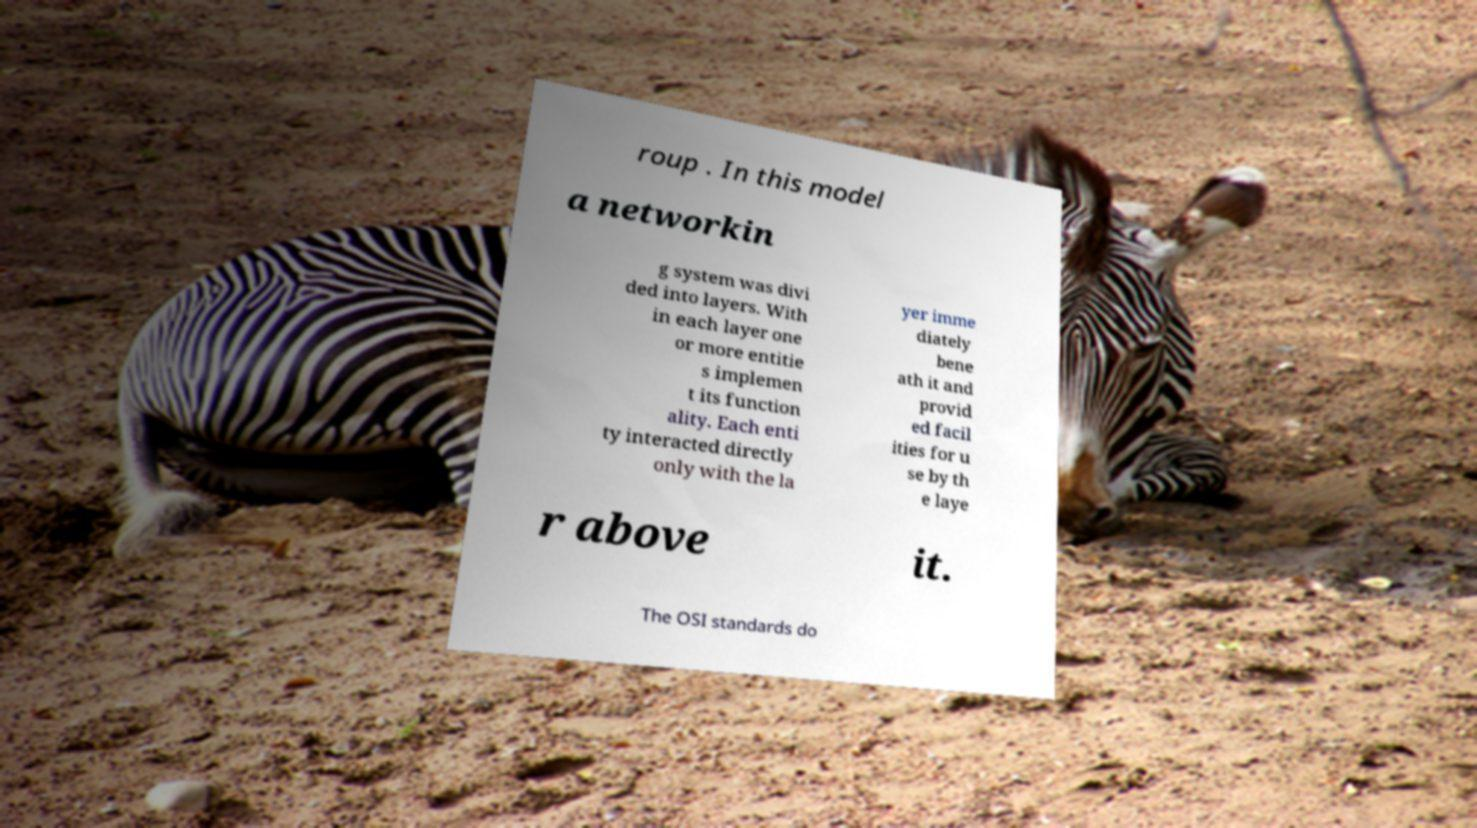Could you assist in decoding the text presented in this image and type it out clearly? roup . In this model a networkin g system was divi ded into layers. With in each layer one or more entitie s implemen t its function ality. Each enti ty interacted directly only with the la yer imme diately bene ath it and provid ed facil ities for u se by th e laye r above it. The OSI standards do 